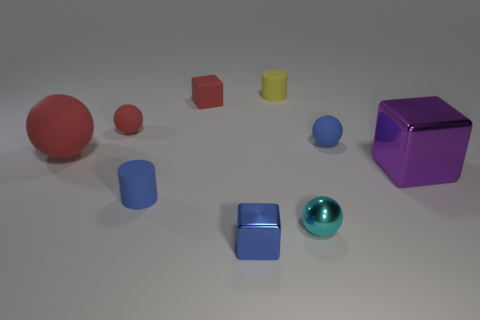Add 1 blue cylinders. How many objects exist? 10 Subtract all spheres. How many objects are left? 5 Add 8 cyan spheres. How many cyan spheres exist? 9 Subtract 0 yellow spheres. How many objects are left? 9 Subtract all tiny blue rubber objects. Subtract all tiny red rubber balls. How many objects are left? 6 Add 7 cubes. How many cubes are left? 10 